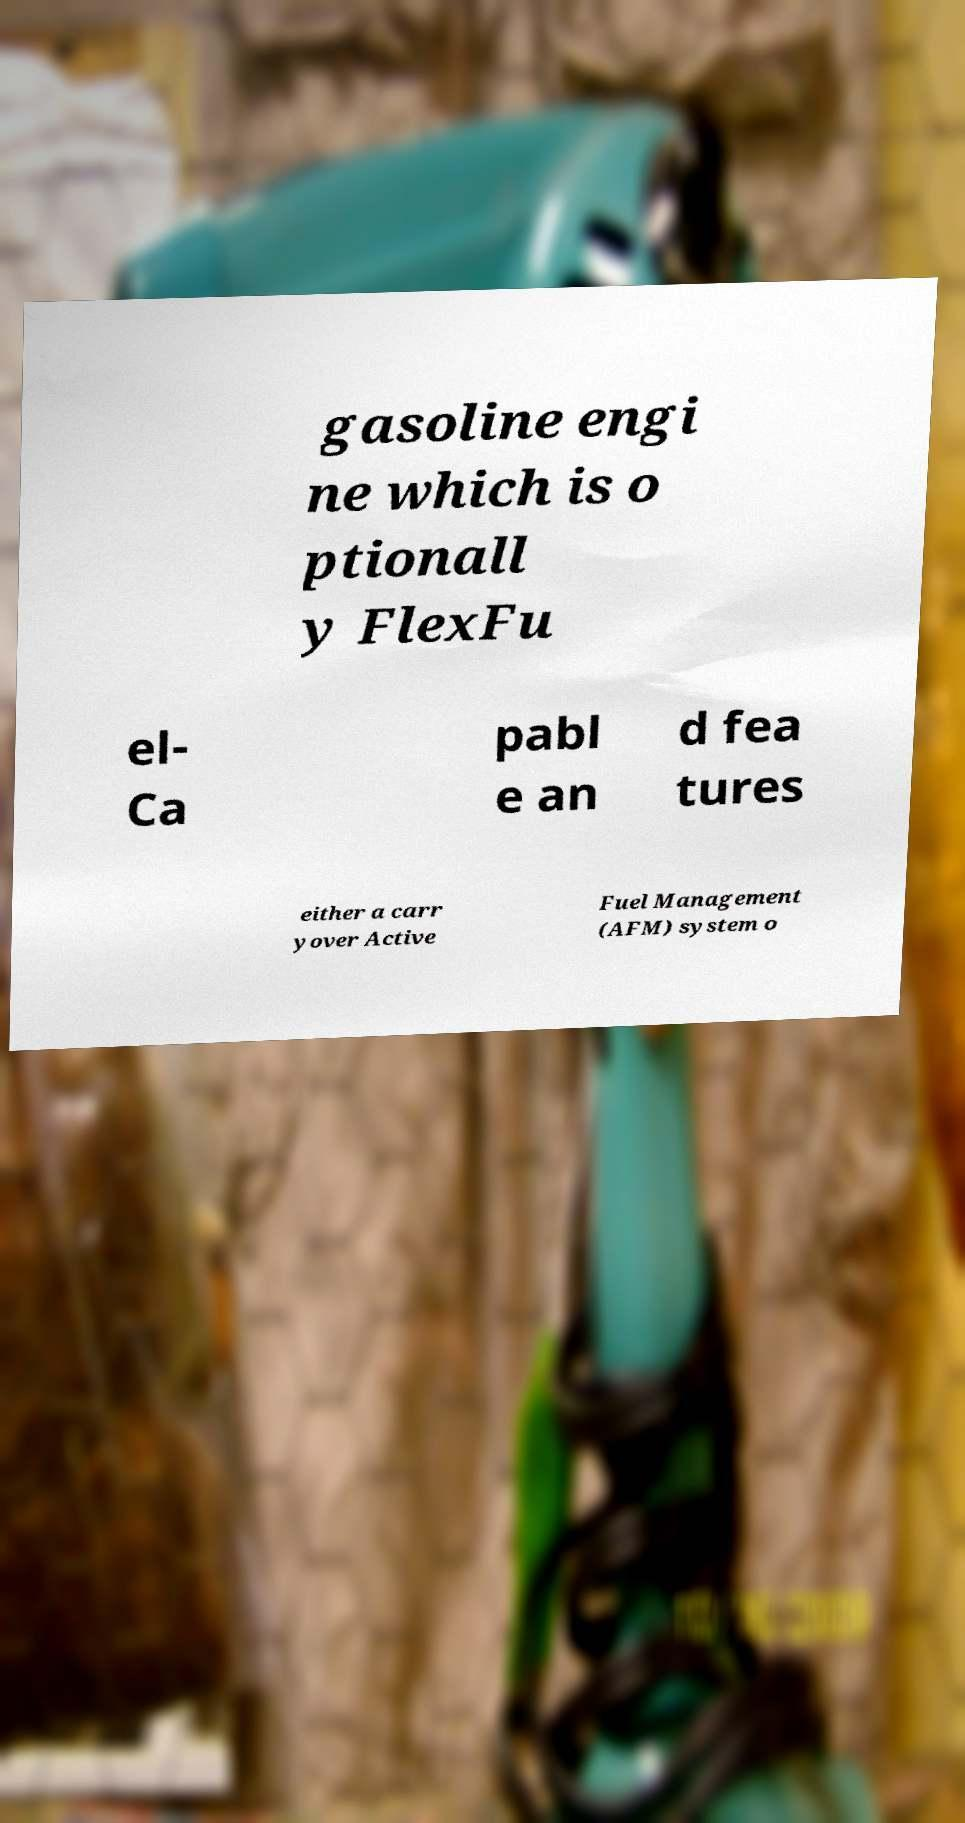Could you extract and type out the text from this image? gasoline engi ne which is o ptionall y FlexFu el- Ca pabl e an d fea tures either a carr yover Active Fuel Management (AFM) system o 